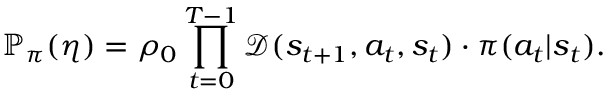Convert formula to latex. <formula><loc_0><loc_0><loc_500><loc_500>\mathbb { P } _ { \pi } ( \eta ) = \rho _ { 0 } \prod _ { t = 0 } ^ { T - 1 } \mathcal { D } ( s _ { t + 1 } , a _ { t } , s _ { t } ) \cdot \pi ( a _ { t } | s _ { t } ) .</formula> 